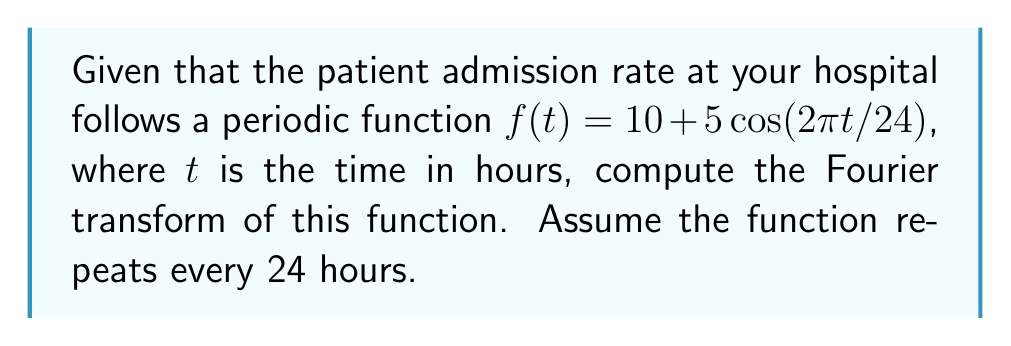Give your solution to this math problem. To compute the Fourier transform of the given periodic function, we'll follow these steps:

1) The Fourier transform of a periodic function is a series of delta functions at the frequencies of the function's components. For a function with period $T$, the frequencies are multiples of $1/T$.

2) Our function has a period of 24 hours, so $T = 24$.

3) The general form of the Fourier transform for a periodic function is:

   $$F(\omega) = \sum_{n=-\infty}^{\infty} c_n \delta(\omega - n\omega_0)$$

   where $\omega_0 = 2\pi/T = 2\pi/24 = \pi/12$ and $c_n$ are the Fourier series coefficients.

4) For our function $f(t) = 10 + 5\cos(2\pi t/24)$, we can identify:
   - $c_0 = 10$ (the constant term)
   - $c_1 = c_{-1} = 5/2$ (half the coefficient of cosine, as $\cos(x) = (e^{ix} + e^{-ix})/2$)
   - All other $c_n = 0$

5) Therefore, our Fourier transform is:

   $$F(\omega) = 10\delta(\omega) + \frac{5}{2}\delta(\omega - \frac{\pi}{12}) + \frac{5}{2}\delta(\omega + \frac{\pi}{12})$$

This represents the frequency components of our periodic patient admission rate function.
Answer: $$F(\omega) = 10\delta(\omega) + \frac{5}{2}\delta(\omega - \frac{\pi}{12}) + \frac{5}{2}\delta(\omega + \frac{\pi}{12})$$ 